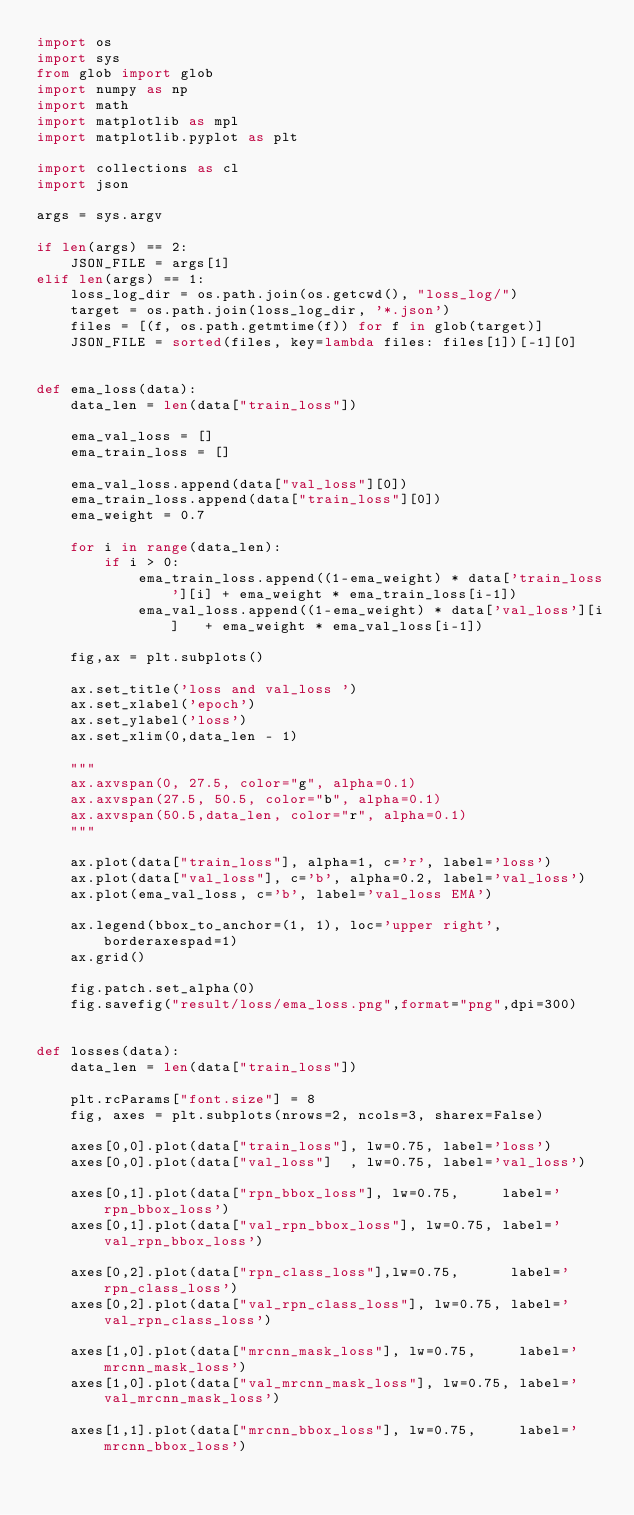<code> <loc_0><loc_0><loc_500><loc_500><_Python_>import os
import sys
from glob import glob
import numpy as np
import math
import matplotlib as mpl
import matplotlib.pyplot as plt

import collections as cl
import json

args = sys.argv

if len(args) == 2:
    JSON_FILE = args[1]
elif len(args) == 1:
    loss_log_dir = os.path.join(os.getcwd(), "loss_log/")
    target = os.path.join(loss_log_dir, '*.json')
    files = [(f, os.path.getmtime(f)) for f in glob(target)]
    JSON_FILE = sorted(files, key=lambda files: files[1])[-1][0]


def ema_loss(data):
    data_len = len(data["train_loss"])

    ema_val_loss = []
    ema_train_loss = []

    ema_val_loss.append(data["val_loss"][0])
    ema_train_loss.append(data["train_loss"][0])
    ema_weight = 0.7

    for i in range(data_len):
        if i > 0:
            ema_train_loss.append((1-ema_weight) * data['train_loss'][i] + ema_weight * ema_train_loss[i-1])
            ema_val_loss.append((1-ema_weight) * data['val_loss'][i]   + ema_weight * ema_val_loss[i-1])

    fig,ax = plt.subplots()

    ax.set_title('loss and val_loss ')
    ax.set_xlabel('epoch')
    ax.set_ylabel('loss')
    ax.set_xlim(0,data_len - 1)

    """
    ax.axvspan(0, 27.5, color="g", alpha=0.1)
    ax.axvspan(27.5, 50.5, color="b", alpha=0.1)
    ax.axvspan(50.5,data_len, color="r", alpha=0.1)
    """

    ax.plot(data["train_loss"], alpha=1, c='r', label='loss')
    ax.plot(data["val_loss"], c='b', alpha=0.2, label='val_loss')
    ax.plot(ema_val_loss, c='b', label='val_loss EMA')

    ax.legend(bbox_to_anchor=(1, 1), loc='upper right', borderaxespad=1)
    ax.grid()

    fig.patch.set_alpha(0)
    fig.savefig("result/loss/ema_loss.png",format="png",dpi=300)


def losses(data):
    data_len = len(data["train_loss"])

    plt.rcParams["font.size"] = 8
    fig, axes = plt.subplots(nrows=2, ncols=3, sharex=False)

    axes[0,0].plot(data["train_loss"], lw=0.75, label='loss')
    axes[0,0].plot(data["val_loss"]  , lw=0.75, label='val_loss')

    axes[0,1].plot(data["rpn_bbox_loss"], lw=0.75,     label='rpn_bbox_loss')
    axes[0,1].plot(data["val_rpn_bbox_loss"], lw=0.75, label='val_rpn_bbox_loss')

    axes[0,2].plot(data["rpn_class_loss"],lw=0.75,      label='rpn_class_loss')
    axes[0,2].plot(data["val_rpn_class_loss"], lw=0.75, label='val_rpn_class_loss')

    axes[1,0].plot(data["mrcnn_mask_loss"], lw=0.75,     label='mrcnn_mask_loss')
    axes[1,0].plot(data["val_mrcnn_mask_loss"], lw=0.75, label='val_mrcnn_mask_loss')

    axes[1,1].plot(data["mrcnn_bbox_loss"], lw=0.75,     label='mrcnn_bbox_loss')</code> 